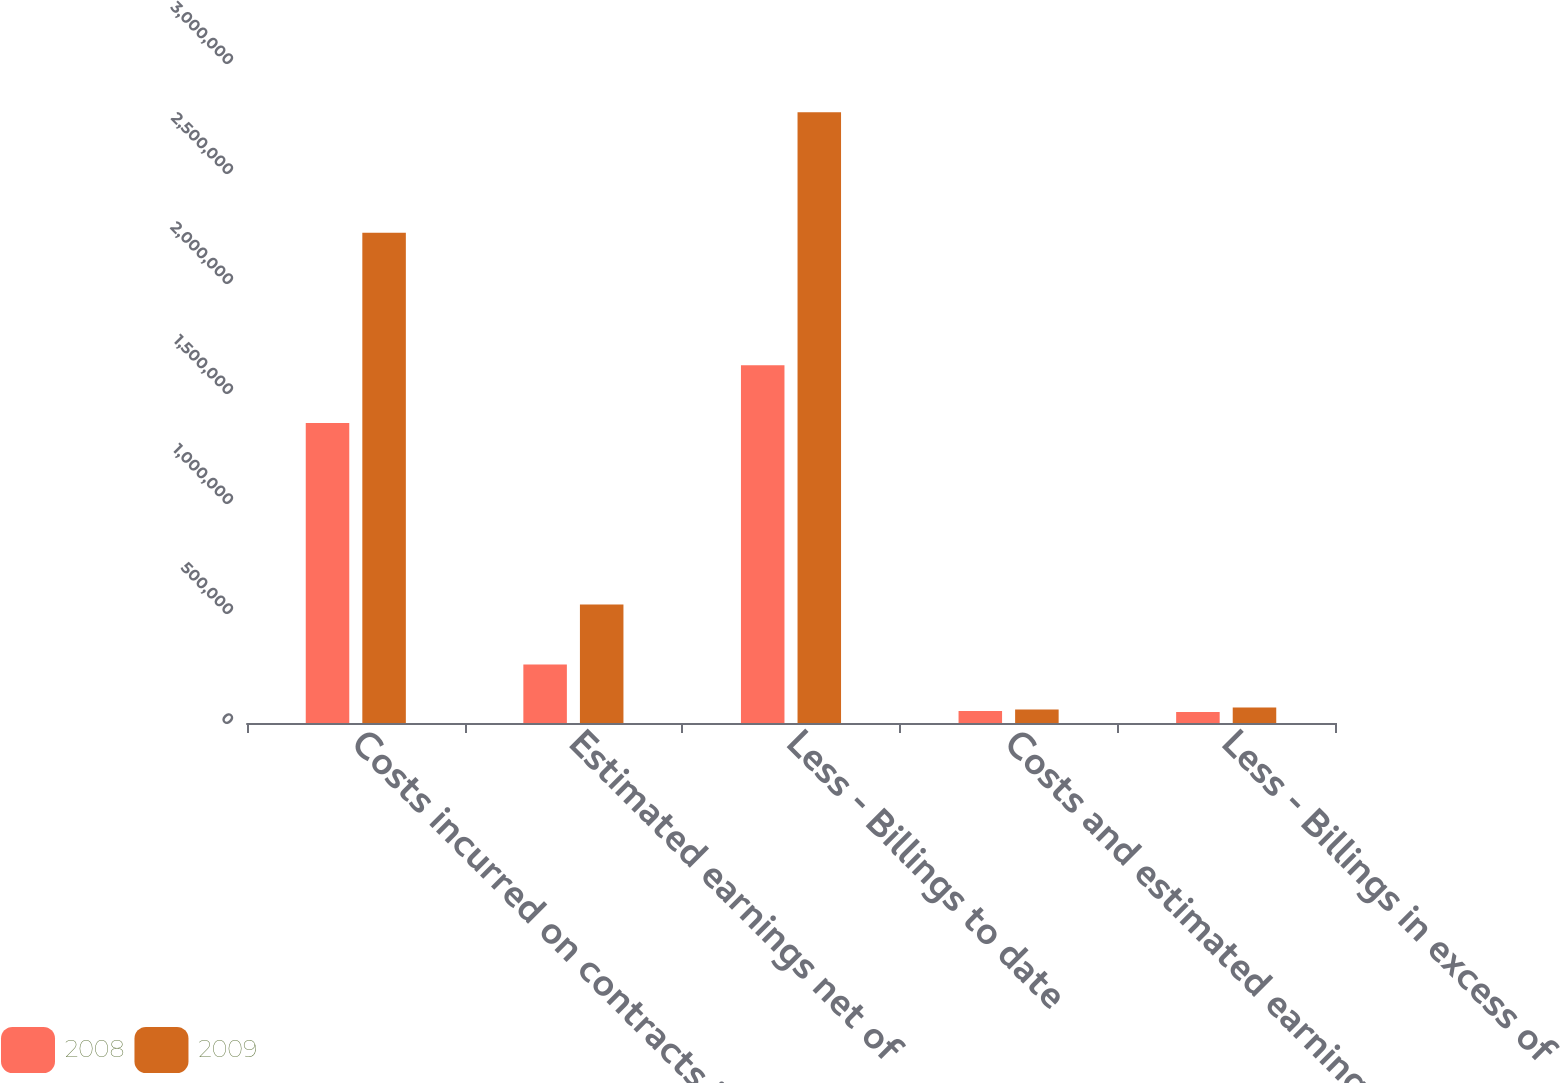Convert chart to OTSL. <chart><loc_0><loc_0><loc_500><loc_500><stacked_bar_chart><ecel><fcel>Costs incurred on contracts in<fcel>Estimated earnings net of<fcel>Less - Billings to date<fcel>Costs and estimated earnings<fcel>Less - Billings in excess of<nl><fcel>2008<fcel>1.36382e+06<fcel>265929<fcel>1.62576e+06<fcel>54379<fcel>50390<nl><fcel>2009<fcel>2.2281e+06<fcel>538668<fcel>2.77576e+06<fcel>61239<fcel>70228<nl></chart> 